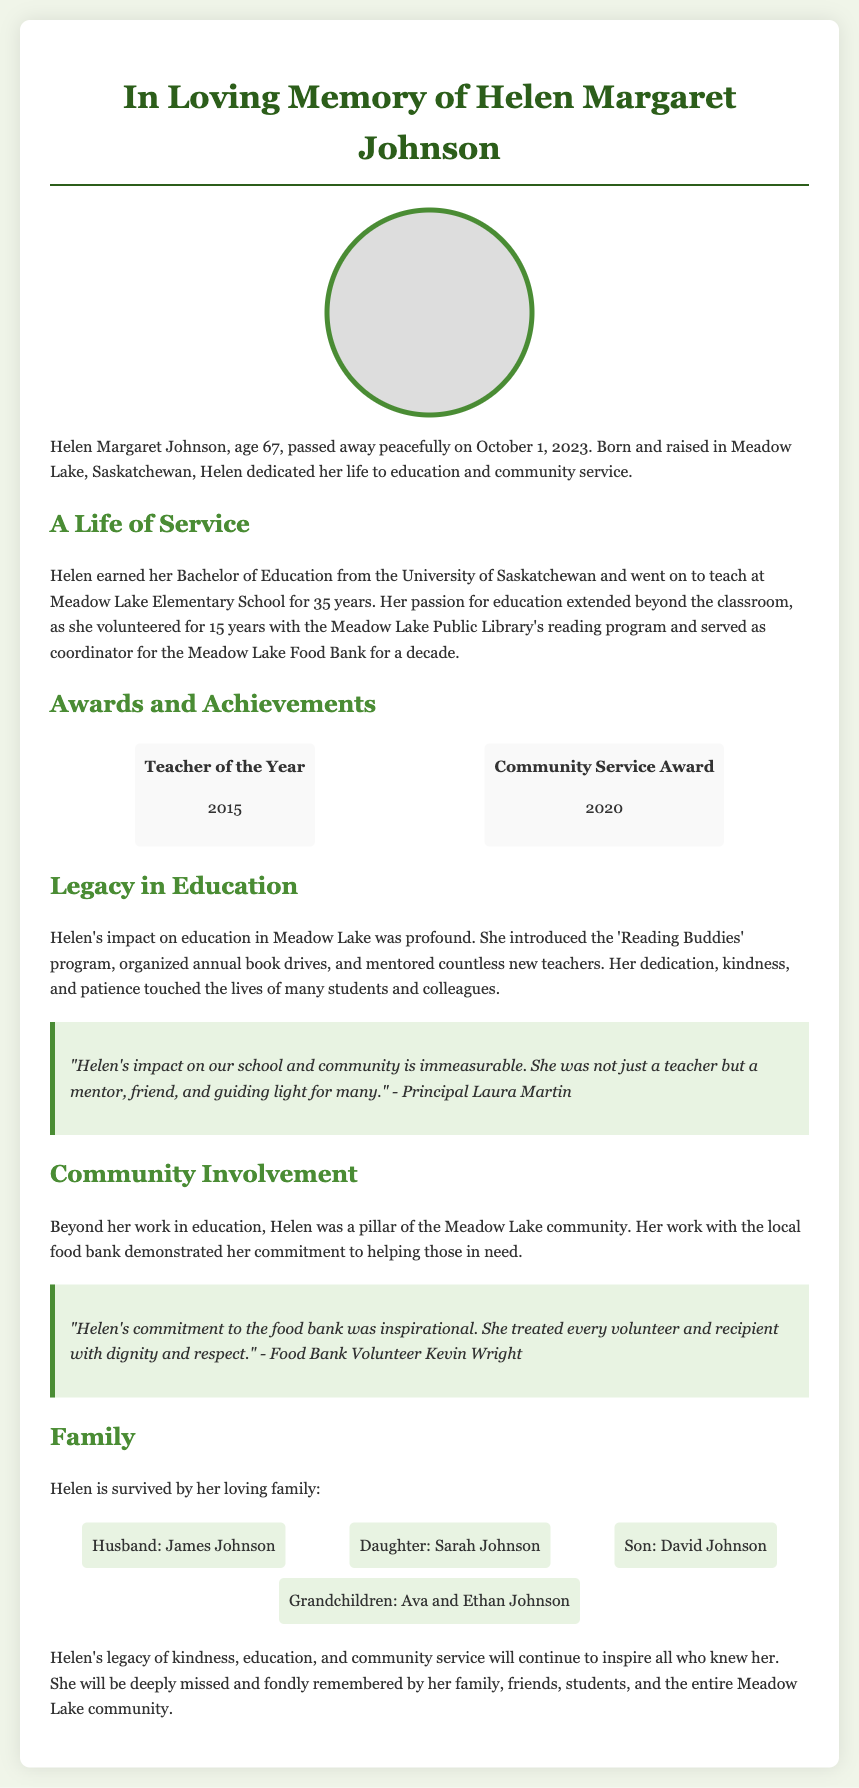What was Helen Johnson's age at the time of her passing? The document states that Helen was 67 years old when she passed away.
Answer: 67 In which year did Helen earn her Bachelor of Education? The document does not specify the exact year, but it implies she completed her education before beginning her 35-year teaching career.
Answer: Not specified How many years did Helen teach at Meadow Lake Elementary School? According to the document, Helen taught at Meadow Lake Elementary School for 35 years.
Answer: 35 years What program did Helen introduce at the school? The document mentions that she introduced the 'Reading Buddies' program.
Answer: Reading Buddies Who described Helen as a "mentor, friend, and guiding light"? The quote from Principal Laura Martin refers to Helen in this way.
Answer: Principal Laura Martin What personal commitment did Helen demonstrate through her work with the food bank? The document states Helen treated every volunteer and recipient with dignity and respect.
Answer: Dignity and respect What year did Helen receive the Teacher of the Year award? The document indicates that Helen received the Teacher of the Year award in 2015.
Answer: 2015 How many grandchildren did Helen have? According to the document, Helen is survived by two grandchildren, Ava and Ethan.
Answer: Two 